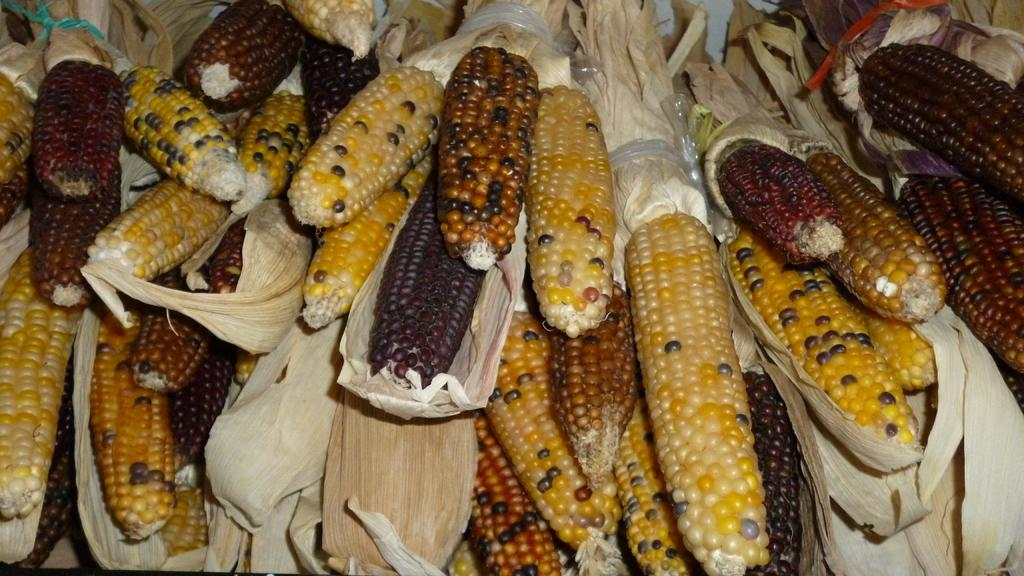What type of food is present in the image? There are sweet corns in the image. Can you describe the appearance of the sweet corns? The sweet corns are in different colors. What type of waves can be seen in the image? There are no waves present in the image; it features sweet corns in different colors. 